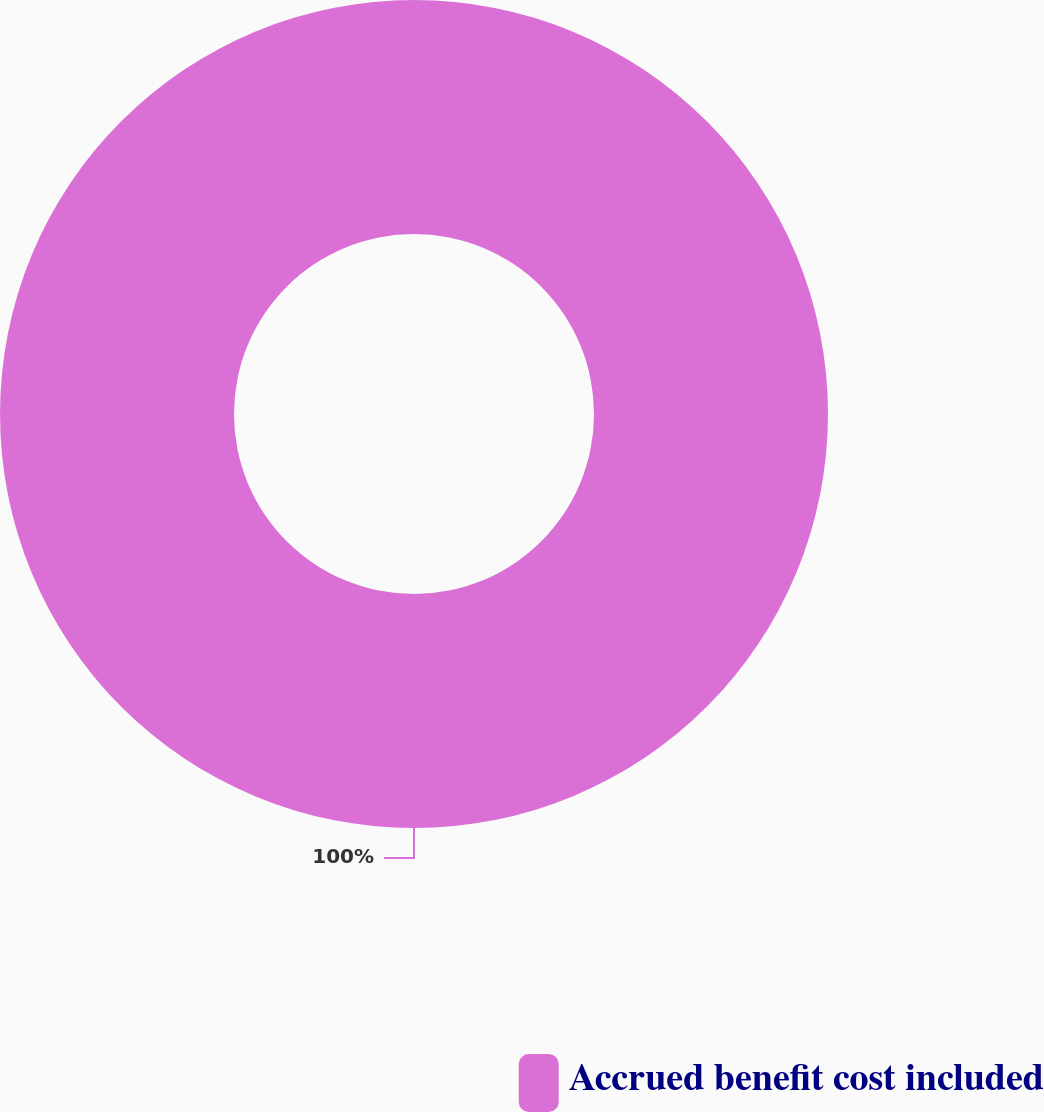Convert chart. <chart><loc_0><loc_0><loc_500><loc_500><pie_chart><fcel>Accrued benefit cost included<nl><fcel>100.0%<nl></chart> 